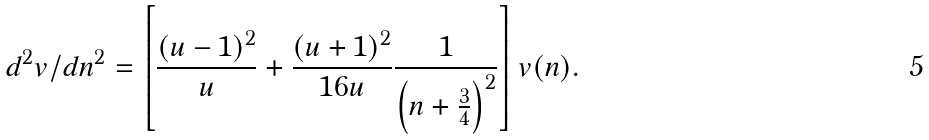<formula> <loc_0><loc_0><loc_500><loc_500>d ^ { 2 } v / d n ^ { 2 } = \left [ \frac { ( u - 1 ) ^ { 2 } } { u } + \frac { ( u + 1 ) ^ { 2 } } { 1 6 u } \frac { 1 } { \left ( n + \frac { 3 } { 4 } \right ) ^ { 2 } } \right ] v ( n ) .</formula> 